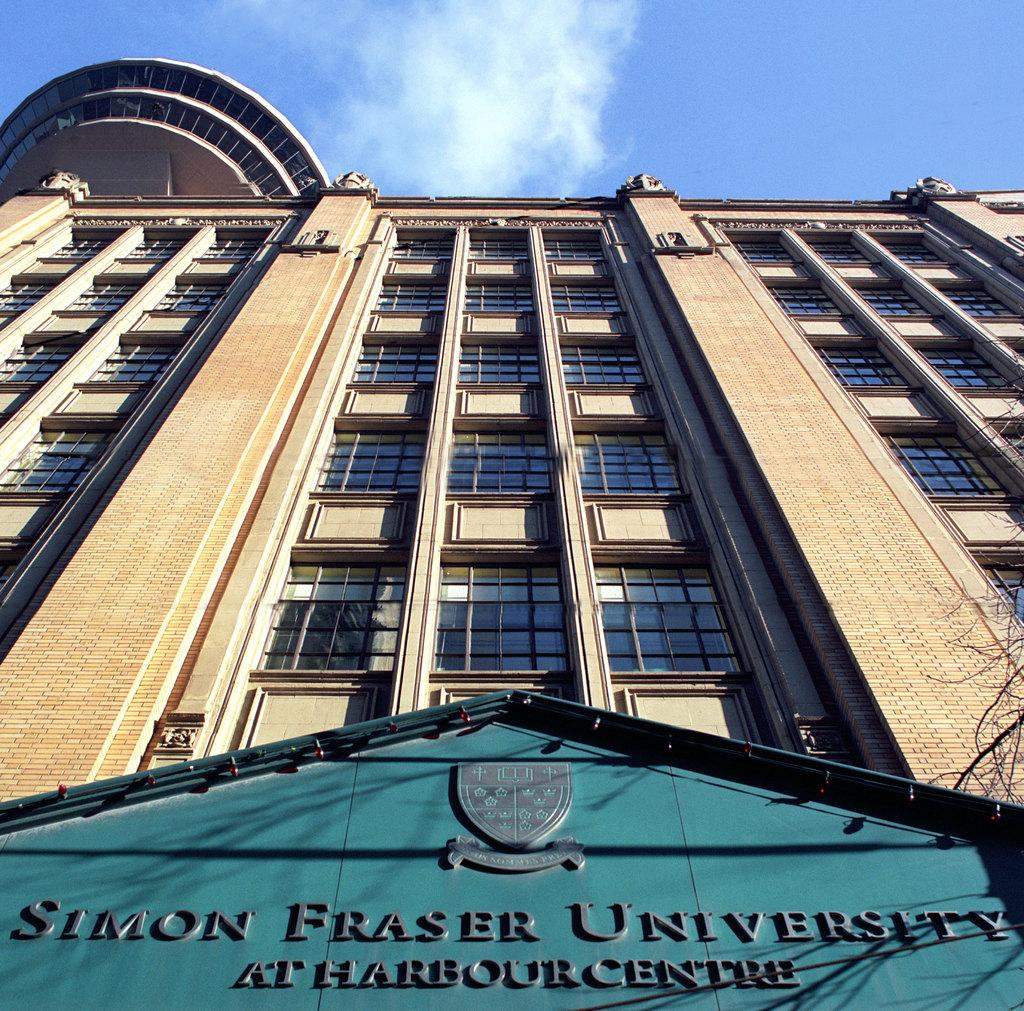What type of structure is visible in the image? There is a building in the image. What feature can be observed on the building? The building has glass windows. What object is present in the image besides the building? There is a board in the image. What is the condition of the tree in the image? There is a dry tree in the image. What colors are visible in the sky in the image? The sky is blue and white in the image. What type of cow can be seen grazing near the building in the image? There is no cow present in the image; it only features a building, a board, a dry tree, and a blue and white sky. 